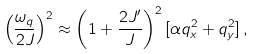Convert formula to latex. <formula><loc_0><loc_0><loc_500><loc_500>\left ( \frac { \omega _ { q } } { 2 J } \right ) ^ { 2 } \approx \left ( 1 + \frac { 2 J ^ { \prime } } { J } \right ) ^ { 2 } [ \alpha q _ { x } ^ { 2 } + q _ { y } ^ { 2 } ] \, ,</formula> 